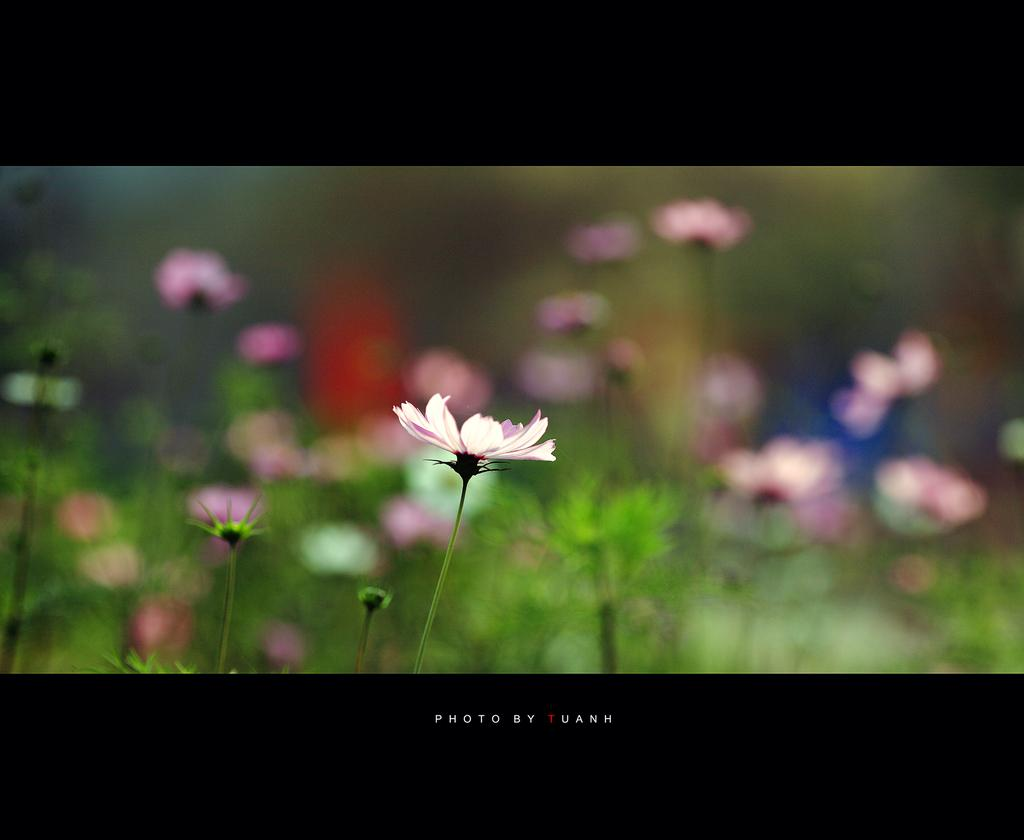What is the main subject of the image? There is a flower in the image. Can you describe the color of the flower? The flower is pink in color. What else can be seen in the background of the image? There are flowers and plants in the background of the image. Is the zebra reading a book in the image? There is no zebra or book present in the image. What type of thing is the flower holding in the image? The flower is not holding anything in the image; it is a stationary object. 